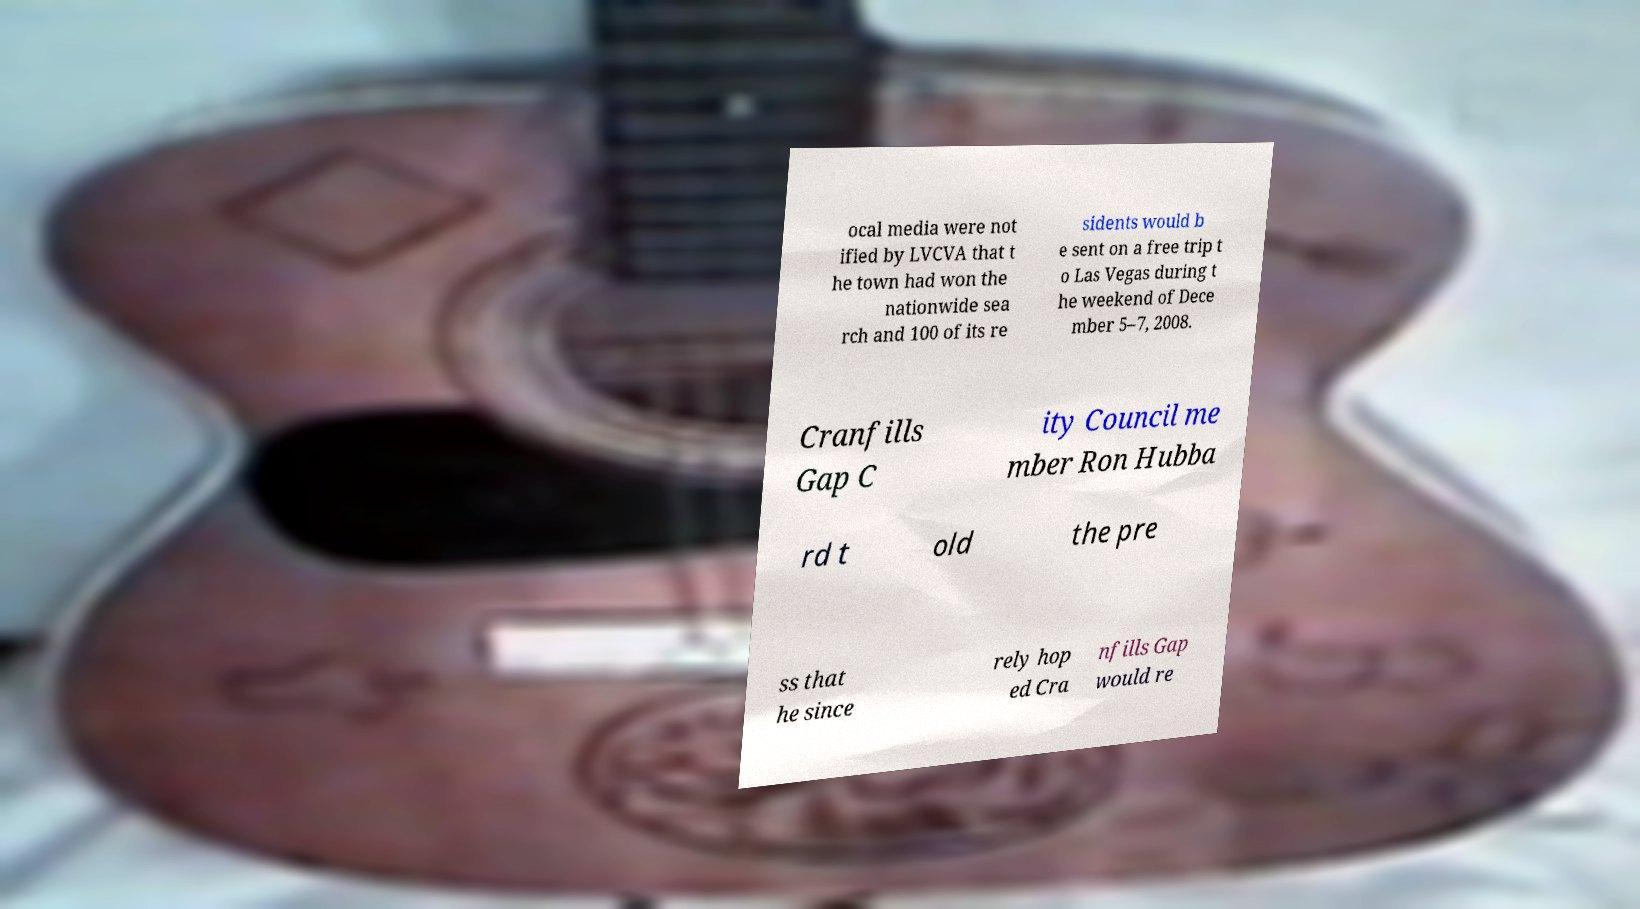Could you extract and type out the text from this image? ocal media were not ified by LVCVA that t he town had won the nationwide sea rch and 100 of its re sidents would b e sent on a free trip t o Las Vegas during t he weekend of Dece mber 5–7, 2008. Cranfills Gap C ity Council me mber Ron Hubba rd t old the pre ss that he since rely hop ed Cra nfills Gap would re 